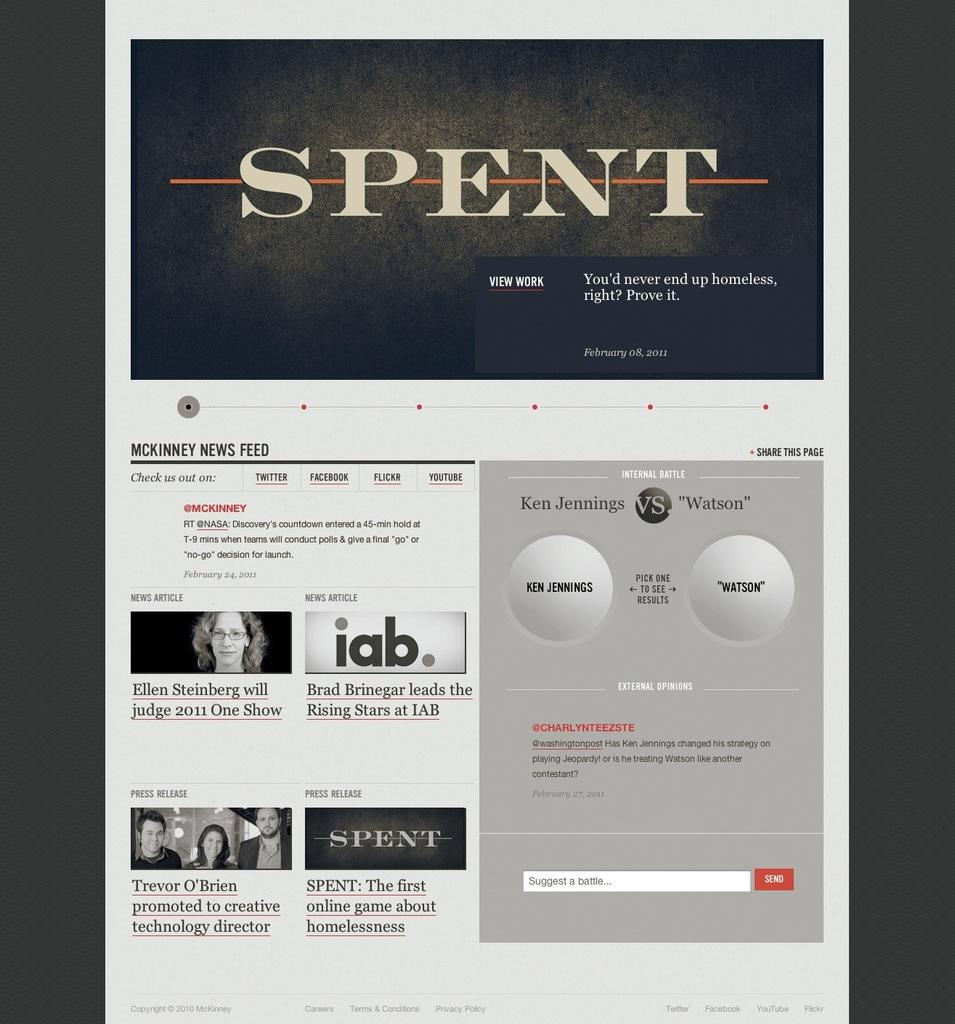<image>
Offer a succinct explanation of the picture presented. Spent is featured in a banner image of a website. 